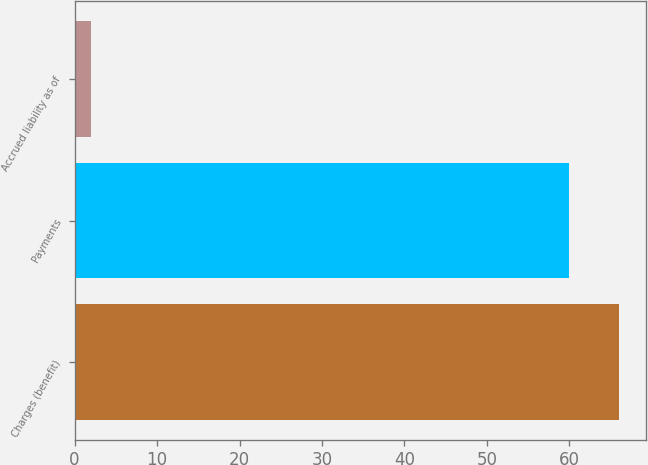Convert chart. <chart><loc_0><loc_0><loc_500><loc_500><bar_chart><fcel>Charges (benefit)<fcel>Payments<fcel>Accrued liability as of<nl><fcel>66<fcel>60<fcel>2<nl></chart> 